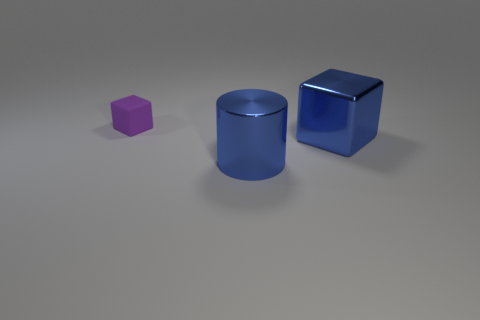There is a tiny purple matte object; what number of blue cylinders are in front of it?
Provide a succinct answer. 1. There is a shiny thing behind the shiny cylinder; what color is it?
Your answer should be very brief. Blue. There is a big metal object that is the same shape as the matte object; what color is it?
Give a very brief answer. Blue. Is there any other thing of the same color as the rubber cube?
Provide a succinct answer. No. Is the number of large blue shiny cylinders greater than the number of large gray metal balls?
Provide a succinct answer. Yes. Is the big blue block made of the same material as the cylinder?
Your answer should be compact. Yes. How many other purple cubes are the same material as the tiny cube?
Offer a terse response. 0. There is a purple matte cube; is it the same size as the cube in front of the tiny matte cube?
Ensure brevity in your answer.  No. The object that is both on the left side of the big blue block and in front of the matte block is what color?
Give a very brief answer. Blue. Is there a big blue block that is behind the large blue object that is on the right side of the blue metal cylinder?
Provide a succinct answer. No. 